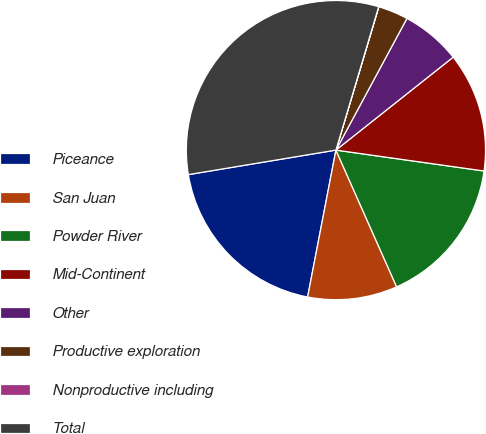Convert chart to OTSL. <chart><loc_0><loc_0><loc_500><loc_500><pie_chart><fcel>Piceance<fcel>San Juan<fcel>Powder River<fcel>Mid-Continent<fcel>Other<fcel>Productive exploration<fcel>Nonproductive including<fcel>Total<nl><fcel>19.35%<fcel>9.68%<fcel>16.12%<fcel>12.9%<fcel>6.46%<fcel>3.24%<fcel>0.02%<fcel>32.23%<nl></chart> 